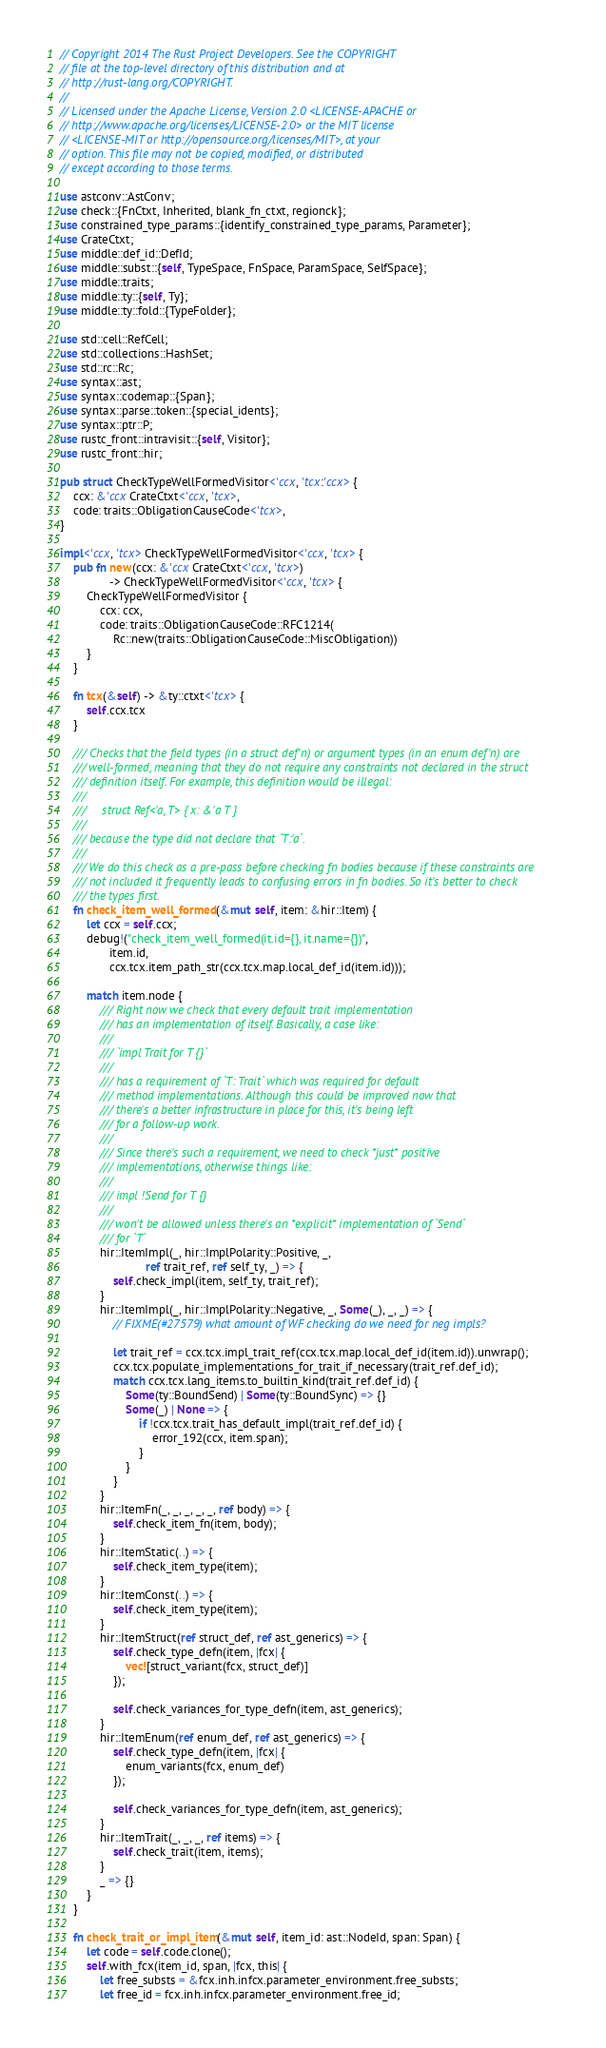Convert code to text. <code><loc_0><loc_0><loc_500><loc_500><_Rust_>// Copyright 2014 The Rust Project Developers. See the COPYRIGHT
// file at the top-level directory of this distribution and at
// http://rust-lang.org/COPYRIGHT.
//
// Licensed under the Apache License, Version 2.0 <LICENSE-APACHE or
// http://www.apache.org/licenses/LICENSE-2.0> or the MIT license
// <LICENSE-MIT or http://opensource.org/licenses/MIT>, at your
// option. This file may not be copied, modified, or distributed
// except according to those terms.

use astconv::AstConv;
use check::{FnCtxt, Inherited, blank_fn_ctxt, regionck};
use constrained_type_params::{identify_constrained_type_params, Parameter};
use CrateCtxt;
use middle::def_id::DefId;
use middle::subst::{self, TypeSpace, FnSpace, ParamSpace, SelfSpace};
use middle::traits;
use middle::ty::{self, Ty};
use middle::ty::fold::{TypeFolder};

use std::cell::RefCell;
use std::collections::HashSet;
use std::rc::Rc;
use syntax::ast;
use syntax::codemap::{Span};
use syntax::parse::token::{special_idents};
use syntax::ptr::P;
use rustc_front::intravisit::{self, Visitor};
use rustc_front::hir;

pub struct CheckTypeWellFormedVisitor<'ccx, 'tcx:'ccx> {
    ccx: &'ccx CrateCtxt<'ccx, 'tcx>,
    code: traits::ObligationCauseCode<'tcx>,
}

impl<'ccx, 'tcx> CheckTypeWellFormedVisitor<'ccx, 'tcx> {
    pub fn new(ccx: &'ccx CrateCtxt<'ccx, 'tcx>)
               -> CheckTypeWellFormedVisitor<'ccx, 'tcx> {
        CheckTypeWellFormedVisitor {
            ccx: ccx,
            code: traits::ObligationCauseCode::RFC1214(
                Rc::new(traits::ObligationCauseCode::MiscObligation))
        }
    }

    fn tcx(&self) -> &ty::ctxt<'tcx> {
        self.ccx.tcx
    }

    /// Checks that the field types (in a struct def'n) or argument types (in an enum def'n) are
    /// well-formed, meaning that they do not require any constraints not declared in the struct
    /// definition itself. For example, this definition would be illegal:
    ///
    ///     struct Ref<'a, T> { x: &'a T }
    ///
    /// because the type did not declare that `T:'a`.
    ///
    /// We do this check as a pre-pass before checking fn bodies because if these constraints are
    /// not included it frequently leads to confusing errors in fn bodies. So it's better to check
    /// the types first.
    fn check_item_well_formed(&mut self, item: &hir::Item) {
        let ccx = self.ccx;
        debug!("check_item_well_formed(it.id={}, it.name={})",
               item.id,
               ccx.tcx.item_path_str(ccx.tcx.map.local_def_id(item.id)));

        match item.node {
            /// Right now we check that every default trait implementation
            /// has an implementation of itself. Basically, a case like:
            ///
            /// `impl Trait for T {}`
            ///
            /// has a requirement of `T: Trait` which was required for default
            /// method implementations. Although this could be improved now that
            /// there's a better infrastructure in place for this, it's being left
            /// for a follow-up work.
            ///
            /// Since there's such a requirement, we need to check *just* positive
            /// implementations, otherwise things like:
            ///
            /// impl !Send for T {}
            ///
            /// won't be allowed unless there's an *explicit* implementation of `Send`
            /// for `T`
            hir::ItemImpl(_, hir::ImplPolarity::Positive, _,
                          ref trait_ref, ref self_ty, _) => {
                self.check_impl(item, self_ty, trait_ref);
            }
            hir::ItemImpl(_, hir::ImplPolarity::Negative, _, Some(_), _, _) => {
                // FIXME(#27579) what amount of WF checking do we need for neg impls?

                let trait_ref = ccx.tcx.impl_trait_ref(ccx.tcx.map.local_def_id(item.id)).unwrap();
                ccx.tcx.populate_implementations_for_trait_if_necessary(trait_ref.def_id);
                match ccx.tcx.lang_items.to_builtin_kind(trait_ref.def_id) {
                    Some(ty::BoundSend) | Some(ty::BoundSync) => {}
                    Some(_) | None => {
                        if !ccx.tcx.trait_has_default_impl(trait_ref.def_id) {
                            error_192(ccx, item.span);
                        }
                    }
                }
            }
            hir::ItemFn(_, _, _, _, _, ref body) => {
                self.check_item_fn(item, body);
            }
            hir::ItemStatic(..) => {
                self.check_item_type(item);
            }
            hir::ItemConst(..) => {
                self.check_item_type(item);
            }
            hir::ItemStruct(ref struct_def, ref ast_generics) => {
                self.check_type_defn(item, |fcx| {
                    vec![struct_variant(fcx, struct_def)]
                });

                self.check_variances_for_type_defn(item, ast_generics);
            }
            hir::ItemEnum(ref enum_def, ref ast_generics) => {
                self.check_type_defn(item, |fcx| {
                    enum_variants(fcx, enum_def)
                });

                self.check_variances_for_type_defn(item, ast_generics);
            }
            hir::ItemTrait(_, _, _, ref items) => {
                self.check_trait(item, items);
            }
            _ => {}
        }
    }

    fn check_trait_or_impl_item(&mut self, item_id: ast::NodeId, span: Span) {
        let code = self.code.clone();
        self.with_fcx(item_id, span, |fcx, this| {
            let free_substs = &fcx.inh.infcx.parameter_environment.free_substs;
            let free_id = fcx.inh.infcx.parameter_environment.free_id;
</code> 